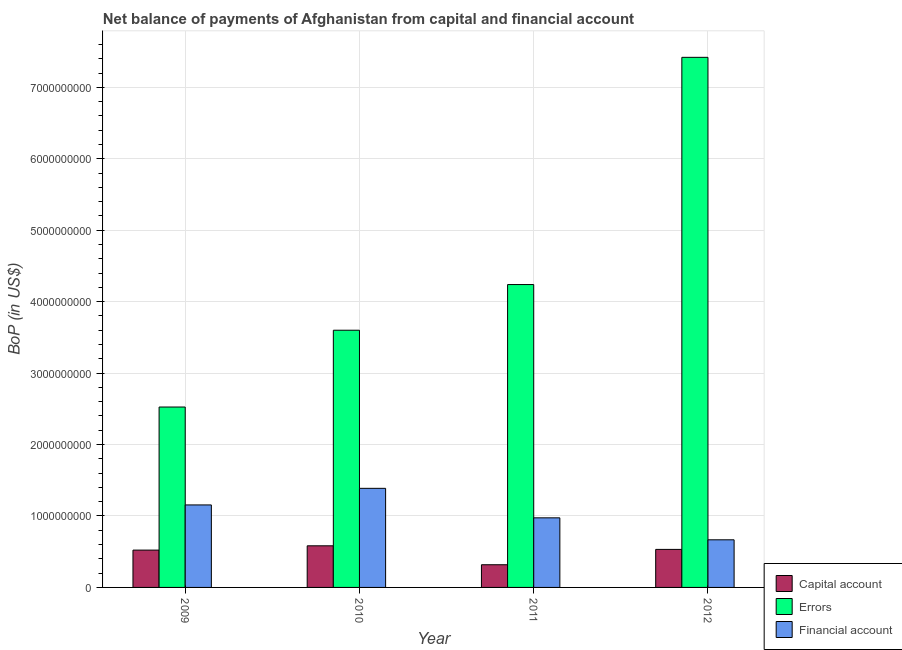How many different coloured bars are there?
Provide a succinct answer. 3. How many groups of bars are there?
Provide a succinct answer. 4. Are the number of bars per tick equal to the number of legend labels?
Provide a succinct answer. Yes. Are the number of bars on each tick of the X-axis equal?
Your response must be concise. Yes. What is the label of the 3rd group of bars from the left?
Offer a terse response. 2011. In how many cases, is the number of bars for a given year not equal to the number of legend labels?
Offer a terse response. 0. What is the amount of net capital account in 2010?
Keep it short and to the point. 5.83e+08. Across all years, what is the maximum amount of net capital account?
Give a very brief answer. 5.83e+08. Across all years, what is the minimum amount of net capital account?
Provide a succinct answer. 3.18e+08. In which year was the amount of financial account maximum?
Give a very brief answer. 2010. What is the total amount of financial account in the graph?
Your answer should be very brief. 4.18e+09. What is the difference between the amount of net capital account in 2010 and that in 2011?
Your answer should be compact. 2.65e+08. What is the difference between the amount of financial account in 2011 and the amount of errors in 2012?
Your answer should be compact. 3.08e+08. What is the average amount of net capital account per year?
Your answer should be compact. 4.89e+08. In the year 2012, what is the difference between the amount of financial account and amount of errors?
Make the answer very short. 0. What is the ratio of the amount of errors in 2009 to that in 2011?
Your answer should be compact. 0.6. Is the amount of net capital account in 2009 less than that in 2011?
Offer a terse response. No. Is the difference between the amount of errors in 2009 and 2010 greater than the difference between the amount of net capital account in 2009 and 2010?
Provide a succinct answer. No. What is the difference between the highest and the second highest amount of financial account?
Provide a short and direct response. 2.32e+08. What is the difference between the highest and the lowest amount of financial account?
Provide a succinct answer. 7.21e+08. What does the 2nd bar from the left in 2012 represents?
Give a very brief answer. Errors. What does the 1st bar from the right in 2010 represents?
Give a very brief answer. Financial account. How many bars are there?
Give a very brief answer. 12. How many years are there in the graph?
Your answer should be compact. 4. What is the difference between two consecutive major ticks on the Y-axis?
Provide a short and direct response. 1.00e+09. Are the values on the major ticks of Y-axis written in scientific E-notation?
Your response must be concise. No. Does the graph contain any zero values?
Your response must be concise. No. How many legend labels are there?
Your answer should be compact. 3. How are the legend labels stacked?
Offer a terse response. Vertical. What is the title of the graph?
Provide a succinct answer. Net balance of payments of Afghanistan from capital and financial account. What is the label or title of the X-axis?
Give a very brief answer. Year. What is the label or title of the Y-axis?
Provide a succinct answer. BoP (in US$). What is the BoP (in US$) in Capital account in 2009?
Your answer should be very brief. 5.23e+08. What is the BoP (in US$) in Errors in 2009?
Your answer should be very brief. 2.53e+09. What is the BoP (in US$) of Financial account in 2009?
Offer a terse response. 1.15e+09. What is the BoP (in US$) in Capital account in 2010?
Ensure brevity in your answer.  5.83e+08. What is the BoP (in US$) of Errors in 2010?
Provide a short and direct response. 3.60e+09. What is the BoP (in US$) in Financial account in 2010?
Make the answer very short. 1.39e+09. What is the BoP (in US$) in Capital account in 2011?
Provide a succinct answer. 3.18e+08. What is the BoP (in US$) in Errors in 2011?
Offer a very short reply. 4.24e+09. What is the BoP (in US$) in Financial account in 2011?
Make the answer very short. 9.74e+08. What is the BoP (in US$) of Capital account in 2012?
Your response must be concise. 5.32e+08. What is the BoP (in US$) of Errors in 2012?
Ensure brevity in your answer.  7.42e+09. What is the BoP (in US$) of Financial account in 2012?
Your answer should be very brief. 6.67e+08. Across all years, what is the maximum BoP (in US$) in Capital account?
Make the answer very short. 5.83e+08. Across all years, what is the maximum BoP (in US$) in Errors?
Offer a terse response. 7.42e+09. Across all years, what is the maximum BoP (in US$) in Financial account?
Keep it short and to the point. 1.39e+09. Across all years, what is the minimum BoP (in US$) in Capital account?
Your response must be concise. 3.18e+08. Across all years, what is the minimum BoP (in US$) of Errors?
Make the answer very short. 2.53e+09. Across all years, what is the minimum BoP (in US$) in Financial account?
Make the answer very short. 6.67e+08. What is the total BoP (in US$) in Capital account in the graph?
Ensure brevity in your answer.  1.95e+09. What is the total BoP (in US$) of Errors in the graph?
Provide a short and direct response. 1.78e+1. What is the total BoP (in US$) of Financial account in the graph?
Provide a short and direct response. 4.18e+09. What is the difference between the BoP (in US$) in Capital account in 2009 and that in 2010?
Make the answer very short. -6.00e+07. What is the difference between the BoP (in US$) of Errors in 2009 and that in 2010?
Your response must be concise. -1.07e+09. What is the difference between the BoP (in US$) in Financial account in 2009 and that in 2010?
Your response must be concise. -2.32e+08. What is the difference between the BoP (in US$) of Capital account in 2009 and that in 2011?
Your response must be concise. 2.05e+08. What is the difference between the BoP (in US$) of Errors in 2009 and that in 2011?
Your response must be concise. -1.71e+09. What is the difference between the BoP (in US$) of Financial account in 2009 and that in 2011?
Keep it short and to the point. 1.81e+08. What is the difference between the BoP (in US$) of Capital account in 2009 and that in 2012?
Give a very brief answer. -9.77e+06. What is the difference between the BoP (in US$) in Errors in 2009 and that in 2012?
Provide a succinct answer. -4.89e+09. What is the difference between the BoP (in US$) in Financial account in 2009 and that in 2012?
Provide a succinct answer. 4.88e+08. What is the difference between the BoP (in US$) in Capital account in 2010 and that in 2011?
Offer a terse response. 2.65e+08. What is the difference between the BoP (in US$) in Errors in 2010 and that in 2011?
Your response must be concise. -6.39e+08. What is the difference between the BoP (in US$) of Financial account in 2010 and that in 2011?
Your answer should be compact. 4.13e+08. What is the difference between the BoP (in US$) in Capital account in 2010 and that in 2012?
Make the answer very short. 5.02e+07. What is the difference between the BoP (in US$) in Errors in 2010 and that in 2012?
Make the answer very short. -3.82e+09. What is the difference between the BoP (in US$) in Financial account in 2010 and that in 2012?
Provide a short and direct response. 7.21e+08. What is the difference between the BoP (in US$) of Capital account in 2011 and that in 2012?
Offer a terse response. -2.15e+08. What is the difference between the BoP (in US$) in Errors in 2011 and that in 2012?
Your answer should be compact. -3.18e+09. What is the difference between the BoP (in US$) in Financial account in 2011 and that in 2012?
Give a very brief answer. 3.08e+08. What is the difference between the BoP (in US$) of Capital account in 2009 and the BoP (in US$) of Errors in 2010?
Provide a succinct answer. -3.08e+09. What is the difference between the BoP (in US$) of Capital account in 2009 and the BoP (in US$) of Financial account in 2010?
Your answer should be compact. -8.65e+08. What is the difference between the BoP (in US$) of Errors in 2009 and the BoP (in US$) of Financial account in 2010?
Keep it short and to the point. 1.14e+09. What is the difference between the BoP (in US$) of Capital account in 2009 and the BoP (in US$) of Errors in 2011?
Ensure brevity in your answer.  -3.72e+09. What is the difference between the BoP (in US$) of Capital account in 2009 and the BoP (in US$) of Financial account in 2011?
Give a very brief answer. -4.52e+08. What is the difference between the BoP (in US$) in Errors in 2009 and the BoP (in US$) in Financial account in 2011?
Offer a very short reply. 1.55e+09. What is the difference between the BoP (in US$) in Capital account in 2009 and the BoP (in US$) in Errors in 2012?
Ensure brevity in your answer.  -6.90e+09. What is the difference between the BoP (in US$) in Capital account in 2009 and the BoP (in US$) in Financial account in 2012?
Ensure brevity in your answer.  -1.44e+08. What is the difference between the BoP (in US$) in Errors in 2009 and the BoP (in US$) in Financial account in 2012?
Provide a short and direct response. 1.86e+09. What is the difference between the BoP (in US$) of Capital account in 2010 and the BoP (in US$) of Errors in 2011?
Offer a terse response. -3.66e+09. What is the difference between the BoP (in US$) of Capital account in 2010 and the BoP (in US$) of Financial account in 2011?
Make the answer very short. -3.92e+08. What is the difference between the BoP (in US$) in Errors in 2010 and the BoP (in US$) in Financial account in 2011?
Give a very brief answer. 2.63e+09. What is the difference between the BoP (in US$) in Capital account in 2010 and the BoP (in US$) in Errors in 2012?
Your answer should be compact. -6.84e+09. What is the difference between the BoP (in US$) of Capital account in 2010 and the BoP (in US$) of Financial account in 2012?
Offer a terse response. -8.41e+07. What is the difference between the BoP (in US$) of Errors in 2010 and the BoP (in US$) of Financial account in 2012?
Your response must be concise. 2.93e+09. What is the difference between the BoP (in US$) in Capital account in 2011 and the BoP (in US$) in Errors in 2012?
Provide a succinct answer. -7.10e+09. What is the difference between the BoP (in US$) in Capital account in 2011 and the BoP (in US$) in Financial account in 2012?
Offer a terse response. -3.49e+08. What is the difference between the BoP (in US$) in Errors in 2011 and the BoP (in US$) in Financial account in 2012?
Give a very brief answer. 3.57e+09. What is the average BoP (in US$) of Capital account per year?
Ensure brevity in your answer.  4.89e+08. What is the average BoP (in US$) in Errors per year?
Provide a succinct answer. 4.45e+09. What is the average BoP (in US$) of Financial account per year?
Provide a short and direct response. 1.05e+09. In the year 2009, what is the difference between the BoP (in US$) in Capital account and BoP (in US$) in Errors?
Ensure brevity in your answer.  -2.00e+09. In the year 2009, what is the difference between the BoP (in US$) of Capital account and BoP (in US$) of Financial account?
Provide a succinct answer. -6.32e+08. In the year 2009, what is the difference between the BoP (in US$) of Errors and BoP (in US$) of Financial account?
Ensure brevity in your answer.  1.37e+09. In the year 2010, what is the difference between the BoP (in US$) in Capital account and BoP (in US$) in Errors?
Give a very brief answer. -3.02e+09. In the year 2010, what is the difference between the BoP (in US$) in Capital account and BoP (in US$) in Financial account?
Provide a short and direct response. -8.05e+08. In the year 2010, what is the difference between the BoP (in US$) in Errors and BoP (in US$) in Financial account?
Keep it short and to the point. 2.21e+09. In the year 2011, what is the difference between the BoP (in US$) of Capital account and BoP (in US$) of Errors?
Your answer should be compact. -3.92e+09. In the year 2011, what is the difference between the BoP (in US$) of Capital account and BoP (in US$) of Financial account?
Provide a short and direct response. -6.57e+08. In the year 2011, what is the difference between the BoP (in US$) in Errors and BoP (in US$) in Financial account?
Your answer should be very brief. 3.27e+09. In the year 2012, what is the difference between the BoP (in US$) in Capital account and BoP (in US$) in Errors?
Your response must be concise. -6.89e+09. In the year 2012, what is the difference between the BoP (in US$) of Capital account and BoP (in US$) of Financial account?
Your response must be concise. -1.34e+08. In the year 2012, what is the difference between the BoP (in US$) of Errors and BoP (in US$) of Financial account?
Provide a short and direct response. 6.75e+09. What is the ratio of the BoP (in US$) in Capital account in 2009 to that in 2010?
Provide a short and direct response. 0.9. What is the ratio of the BoP (in US$) of Errors in 2009 to that in 2010?
Your response must be concise. 0.7. What is the ratio of the BoP (in US$) in Financial account in 2009 to that in 2010?
Your answer should be very brief. 0.83. What is the ratio of the BoP (in US$) in Capital account in 2009 to that in 2011?
Your response must be concise. 1.65. What is the ratio of the BoP (in US$) in Errors in 2009 to that in 2011?
Give a very brief answer. 0.6. What is the ratio of the BoP (in US$) of Financial account in 2009 to that in 2011?
Your response must be concise. 1.19. What is the ratio of the BoP (in US$) in Capital account in 2009 to that in 2012?
Provide a succinct answer. 0.98. What is the ratio of the BoP (in US$) in Errors in 2009 to that in 2012?
Provide a succinct answer. 0.34. What is the ratio of the BoP (in US$) in Financial account in 2009 to that in 2012?
Your answer should be compact. 1.73. What is the ratio of the BoP (in US$) in Capital account in 2010 to that in 2011?
Make the answer very short. 1.83. What is the ratio of the BoP (in US$) in Errors in 2010 to that in 2011?
Give a very brief answer. 0.85. What is the ratio of the BoP (in US$) of Financial account in 2010 to that in 2011?
Offer a terse response. 1.42. What is the ratio of the BoP (in US$) in Capital account in 2010 to that in 2012?
Ensure brevity in your answer.  1.09. What is the ratio of the BoP (in US$) of Errors in 2010 to that in 2012?
Provide a short and direct response. 0.49. What is the ratio of the BoP (in US$) of Financial account in 2010 to that in 2012?
Make the answer very short. 2.08. What is the ratio of the BoP (in US$) in Capital account in 2011 to that in 2012?
Provide a short and direct response. 0.6. What is the ratio of the BoP (in US$) in Errors in 2011 to that in 2012?
Your response must be concise. 0.57. What is the ratio of the BoP (in US$) in Financial account in 2011 to that in 2012?
Make the answer very short. 1.46. What is the difference between the highest and the second highest BoP (in US$) of Capital account?
Your response must be concise. 5.02e+07. What is the difference between the highest and the second highest BoP (in US$) of Errors?
Your response must be concise. 3.18e+09. What is the difference between the highest and the second highest BoP (in US$) in Financial account?
Your answer should be very brief. 2.32e+08. What is the difference between the highest and the lowest BoP (in US$) of Capital account?
Provide a short and direct response. 2.65e+08. What is the difference between the highest and the lowest BoP (in US$) in Errors?
Your answer should be very brief. 4.89e+09. What is the difference between the highest and the lowest BoP (in US$) of Financial account?
Offer a very short reply. 7.21e+08. 